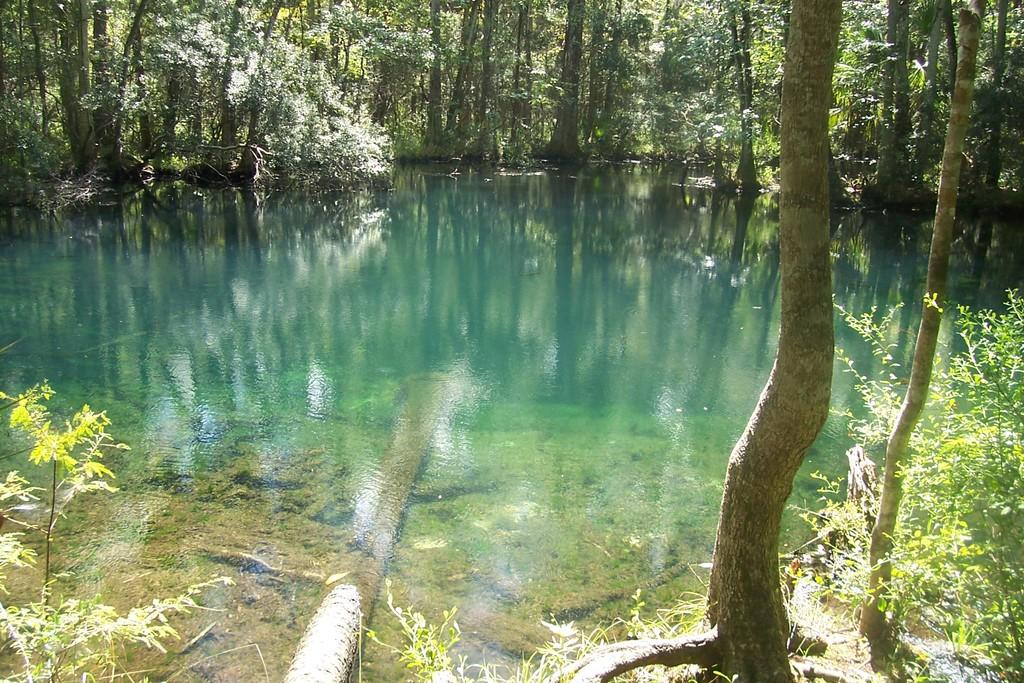What type of natural environment can be seen in the background of the image? There are trees in the background of the image. What is the main feature in the image? There is a water body in the image. What type of vegetation is present in the image? There are plants in the image. How many snails can be seen crawling on the heart in the image? There is no heart or snails present in the image. What type of root system can be observed in the image? There is no root system visible in the image; it features trees, a water body, and plants. 